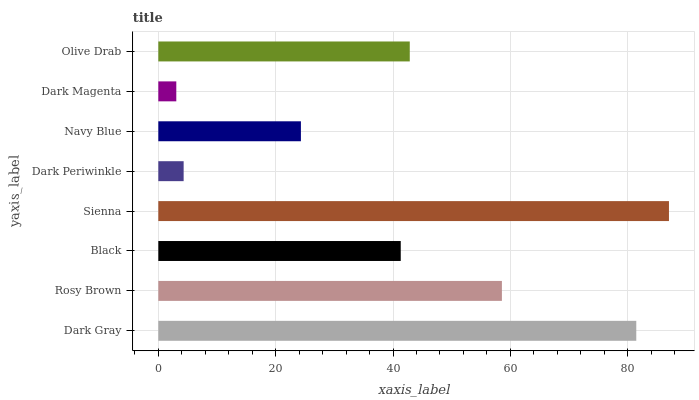Is Dark Magenta the minimum?
Answer yes or no. Yes. Is Sienna the maximum?
Answer yes or no. Yes. Is Rosy Brown the minimum?
Answer yes or no. No. Is Rosy Brown the maximum?
Answer yes or no. No. Is Dark Gray greater than Rosy Brown?
Answer yes or no. Yes. Is Rosy Brown less than Dark Gray?
Answer yes or no. Yes. Is Rosy Brown greater than Dark Gray?
Answer yes or no. No. Is Dark Gray less than Rosy Brown?
Answer yes or no. No. Is Olive Drab the high median?
Answer yes or no. Yes. Is Black the low median?
Answer yes or no. Yes. Is Navy Blue the high median?
Answer yes or no. No. Is Rosy Brown the low median?
Answer yes or no. No. 